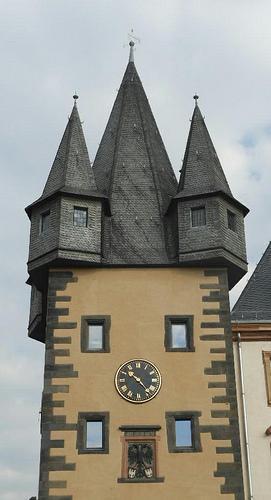How many clocks are shown?
Give a very brief answer. 1. How many steeples can be seen?
Give a very brief answer. 3. How many windows are near the clock?
Give a very brief answer. 4. 